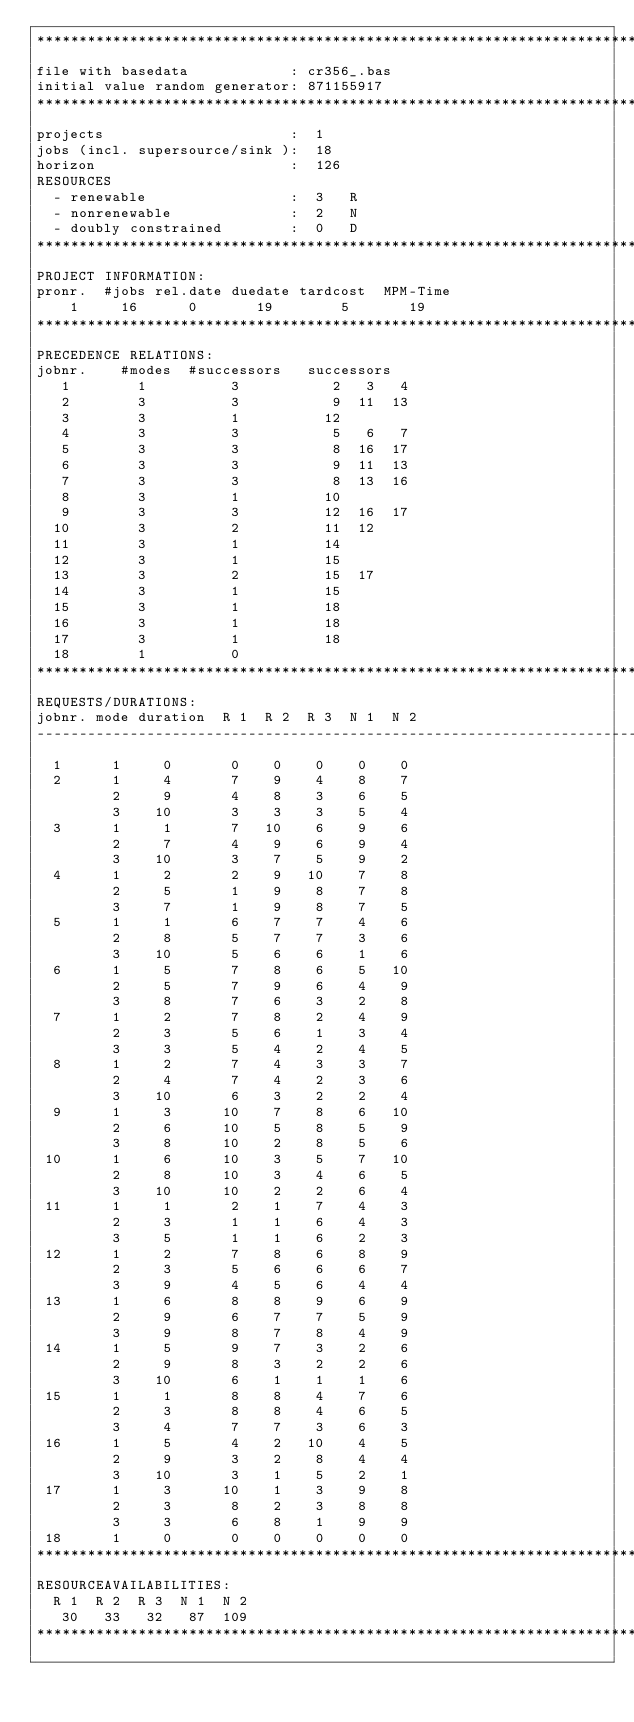Convert code to text. <code><loc_0><loc_0><loc_500><loc_500><_ObjectiveC_>************************************************************************
file with basedata            : cr356_.bas
initial value random generator: 871155917
************************************************************************
projects                      :  1
jobs (incl. supersource/sink ):  18
horizon                       :  126
RESOURCES
  - renewable                 :  3   R
  - nonrenewable              :  2   N
  - doubly constrained        :  0   D
************************************************************************
PROJECT INFORMATION:
pronr.  #jobs rel.date duedate tardcost  MPM-Time
    1     16      0       19        5       19
************************************************************************
PRECEDENCE RELATIONS:
jobnr.    #modes  #successors   successors
   1        1          3           2   3   4
   2        3          3           9  11  13
   3        3          1          12
   4        3          3           5   6   7
   5        3          3           8  16  17
   6        3          3           9  11  13
   7        3          3           8  13  16
   8        3          1          10
   9        3          3          12  16  17
  10        3          2          11  12
  11        3          1          14
  12        3          1          15
  13        3          2          15  17
  14        3          1          15
  15        3          1          18
  16        3          1          18
  17        3          1          18
  18        1          0        
************************************************************************
REQUESTS/DURATIONS:
jobnr. mode duration  R 1  R 2  R 3  N 1  N 2
------------------------------------------------------------------------
  1      1     0       0    0    0    0    0
  2      1     4       7    9    4    8    7
         2     9       4    8    3    6    5
         3    10       3    3    3    5    4
  3      1     1       7   10    6    9    6
         2     7       4    9    6    9    4
         3    10       3    7    5    9    2
  4      1     2       2    9   10    7    8
         2     5       1    9    8    7    8
         3     7       1    9    8    7    5
  5      1     1       6    7    7    4    6
         2     8       5    7    7    3    6
         3    10       5    6    6    1    6
  6      1     5       7    8    6    5   10
         2     5       7    9    6    4    9
         3     8       7    6    3    2    8
  7      1     2       7    8    2    4    9
         2     3       5    6    1    3    4
         3     3       5    4    2    4    5
  8      1     2       7    4    3    3    7
         2     4       7    4    2    3    6
         3    10       6    3    2    2    4
  9      1     3      10    7    8    6   10
         2     6      10    5    8    5    9
         3     8      10    2    8    5    6
 10      1     6      10    3    5    7   10
         2     8      10    3    4    6    5
         3    10      10    2    2    6    4
 11      1     1       2    1    7    4    3
         2     3       1    1    6    4    3
         3     5       1    1    6    2    3
 12      1     2       7    8    6    8    9
         2     3       5    6    6    6    7
         3     9       4    5    6    4    4
 13      1     6       8    8    9    6    9
         2     9       6    7    7    5    9
         3     9       8    7    8    4    9
 14      1     5       9    7    3    2    6
         2     9       8    3    2    2    6
         3    10       6    1    1    1    6
 15      1     1       8    8    4    7    6
         2     3       8    8    4    6    5
         3     4       7    7    3    6    3
 16      1     5       4    2   10    4    5
         2     9       3    2    8    4    4
         3    10       3    1    5    2    1
 17      1     3      10    1    3    9    8
         2     3       8    2    3    8    8
         3     3       6    8    1    9    9
 18      1     0       0    0    0    0    0
************************************************************************
RESOURCEAVAILABILITIES:
  R 1  R 2  R 3  N 1  N 2
   30   33   32   87  109
************************************************************************
</code> 